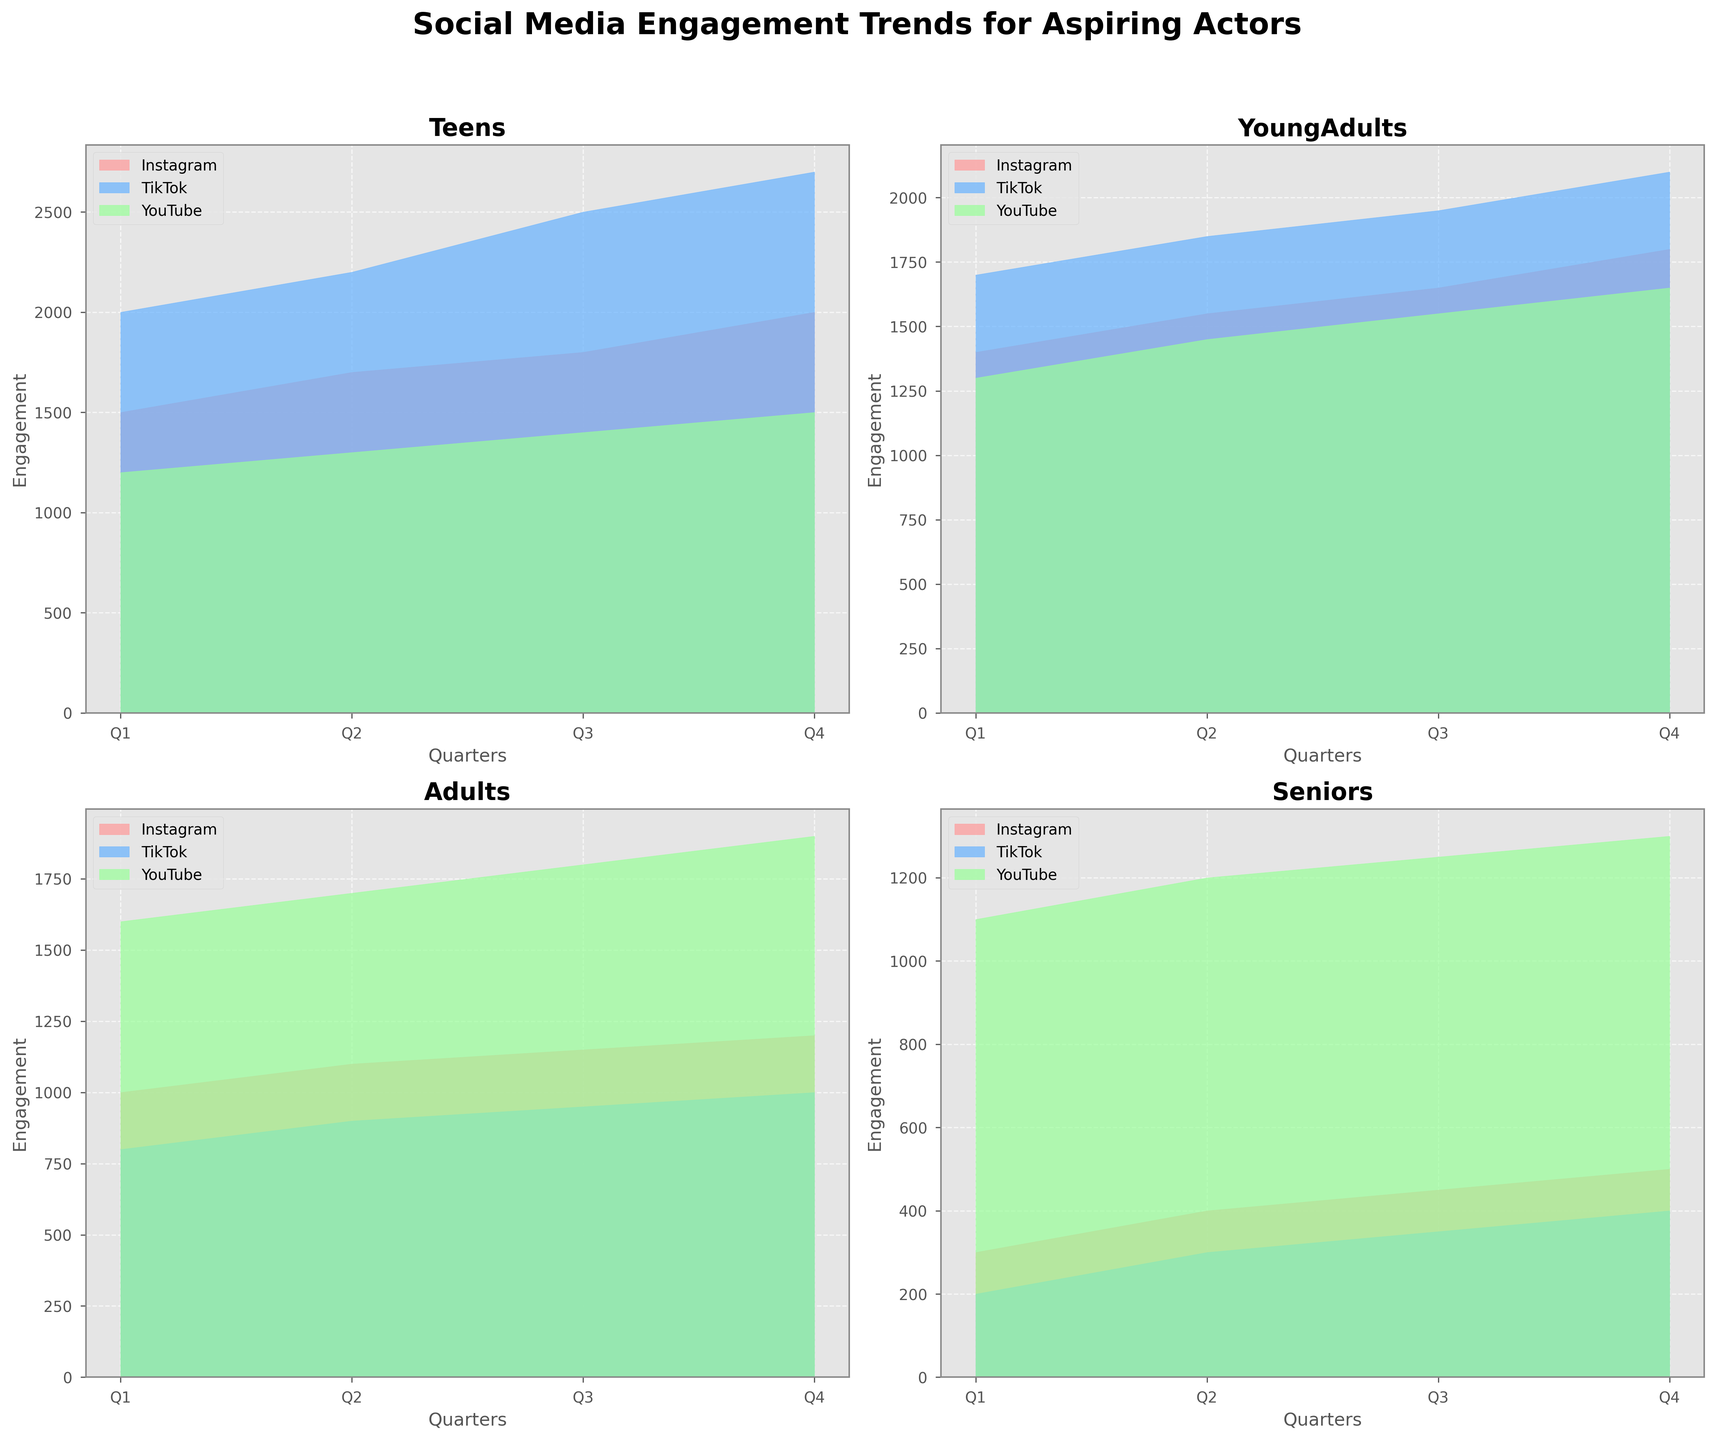What is the title of the plot? The title of the plot is explicitly shown at the top of the overall figure. It reads "Social Media Engagement Trends for Aspiring Actors".
Answer: Social Media Engagement Trends for Aspiring Actors Which demographic group shows the highest engagement for TikTok in Q4? To find out which demographic group has the highest engagement for TikTok in Q4, we need to compare the top edges of the filled areas for TikTok in each subplot for Q4. Teens have 2700, Young Adults have 2100, Adults have 1000, and Seniors have 400. Thus, Teens have the highest engagement.
Answer: Teens What is the average engagement for YouTube among Young Adults across all quarters? To calculate the average engagement for YouTube among Young Adults, sum the engagement values for YouTube from Q1 to Q4 and divide by the number of quarters. The values are 1300, 1450, 1550, and 1650. So, (1300 + 1450 + 1550 + 1650) / 4 = 1475.
Answer: 1475 In which quarter do Seniors have the highest engagement on Instagram? To determine the quarter with the highest engagement for Seniors on Instagram, look at the filled area for Instagram in the Seniors' subplot and see which quarter has the highest top edge. The engagements are increasing from Q1 (300), Q2 (400), Q3 (450), and Q4 (500). Thus, Q4 has the highest engagement.
Answer: Q4 How does the engagement trend for YouTube among Adults compare to TikTok in the same group? By examining the subplot for Adults, we can see that the engagement trend for YouTube is continuously higher than that of TikTok in each quarter. YouTube starts at 1600 in Q1 and ends at 1900 in Q4, while TikTok starts at 800 in Q1 and ends at 1000 in Q4. Thus, YouTube has higher engagement than TikTok in all quarters.
Answer: YouTube has higher engagement Which platform has a decreasing trend in engagement among Seniors? To determine which platform shows a decreasing trend among Seniors, inspect the filled areas for each platform in the Seniors' subplot. Instagram and YouTube both show an increasing trend. Only TikTok starts at 200 in Q1 and ends at 400 in Q4, meaning it does not decrease. Thus, none of the platforms show a decreasing trend.
Answer: None What is the total engagement for Instagram among Teens across all quarters? To get the total engagement for Instagram among Teens, sum the engagement values over Q1, Q2, Q3, and Q4. The values are 1500, 1700, 1800, and 2000. So, 1500 + 1700 + 1800 + 2000 = 7000.
Answer: 7000 Which demographic has the lowest total engagement across all platforms and quarters? To find the demographic with the lowest total engagement, sum the engagement values for each platform across all quarters and add them for all platforms in each demographic group. Summing up: Teens = (1500+1700+1800+2000) + (2000+2200+2500+2700) + (1200+1300+1400+1500) = 20700; Young Adults = (1400+1550+1650+1800) + (1700+1850+1950+2100) + (1300+1450+1550+1650) = 18950; Adults = (1000+1100+1150+1200) + (800+900+950+1000) + (1600+1700+1800+1900) = 14350; Seniors = (300+400+450+500) + (200+300+350+400) + (1100+1200+1250+1300) = 8250. The Seniors have the lowest engagement.
Answer: Seniors Which platform has the lowest engagement for Young Adults in Q3? To find the platform with the lowest engagement for Young Adults in Q3, compare the engagement values of Instagram (1650), TikTok (1950), and YouTube (1550) in Q3 from the Young Adults' subplot. Thus, YouTube has the lowest engagement in Q3 with 1550.
Answer: YouTube 